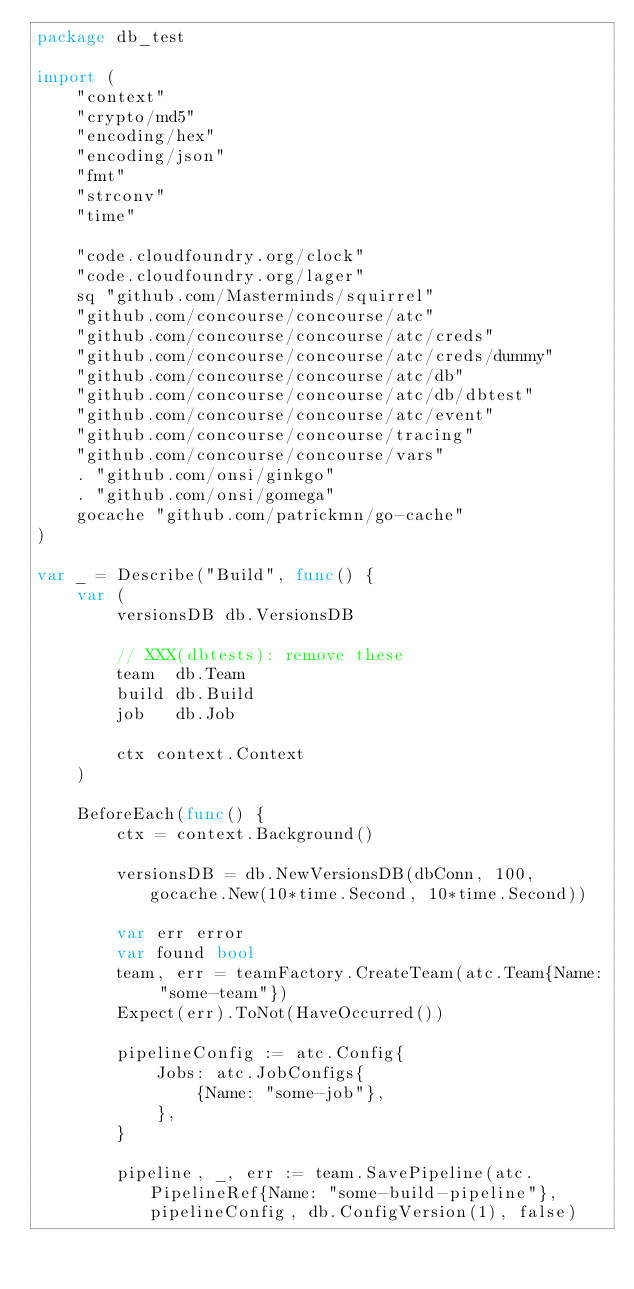<code> <loc_0><loc_0><loc_500><loc_500><_Go_>package db_test

import (
	"context"
	"crypto/md5"
	"encoding/hex"
	"encoding/json"
	"fmt"
	"strconv"
	"time"

	"code.cloudfoundry.org/clock"
	"code.cloudfoundry.org/lager"
	sq "github.com/Masterminds/squirrel"
	"github.com/concourse/concourse/atc"
	"github.com/concourse/concourse/atc/creds"
	"github.com/concourse/concourse/atc/creds/dummy"
	"github.com/concourse/concourse/atc/db"
	"github.com/concourse/concourse/atc/db/dbtest"
	"github.com/concourse/concourse/atc/event"
	"github.com/concourse/concourse/tracing"
	"github.com/concourse/concourse/vars"
	. "github.com/onsi/ginkgo"
	. "github.com/onsi/gomega"
	gocache "github.com/patrickmn/go-cache"
)

var _ = Describe("Build", func() {
	var (
		versionsDB db.VersionsDB

		// XXX(dbtests): remove these
		team  db.Team
		build db.Build
		job   db.Job

		ctx context.Context
	)

	BeforeEach(func() {
		ctx = context.Background()

		versionsDB = db.NewVersionsDB(dbConn, 100, gocache.New(10*time.Second, 10*time.Second))

		var err error
		var found bool
		team, err = teamFactory.CreateTeam(atc.Team{Name: "some-team"})
		Expect(err).ToNot(HaveOccurred())

		pipelineConfig := atc.Config{
			Jobs: atc.JobConfigs{
				{Name: "some-job"},
			},
		}

		pipeline, _, err := team.SavePipeline(atc.PipelineRef{Name: "some-build-pipeline"}, pipelineConfig, db.ConfigVersion(1), false)</code> 